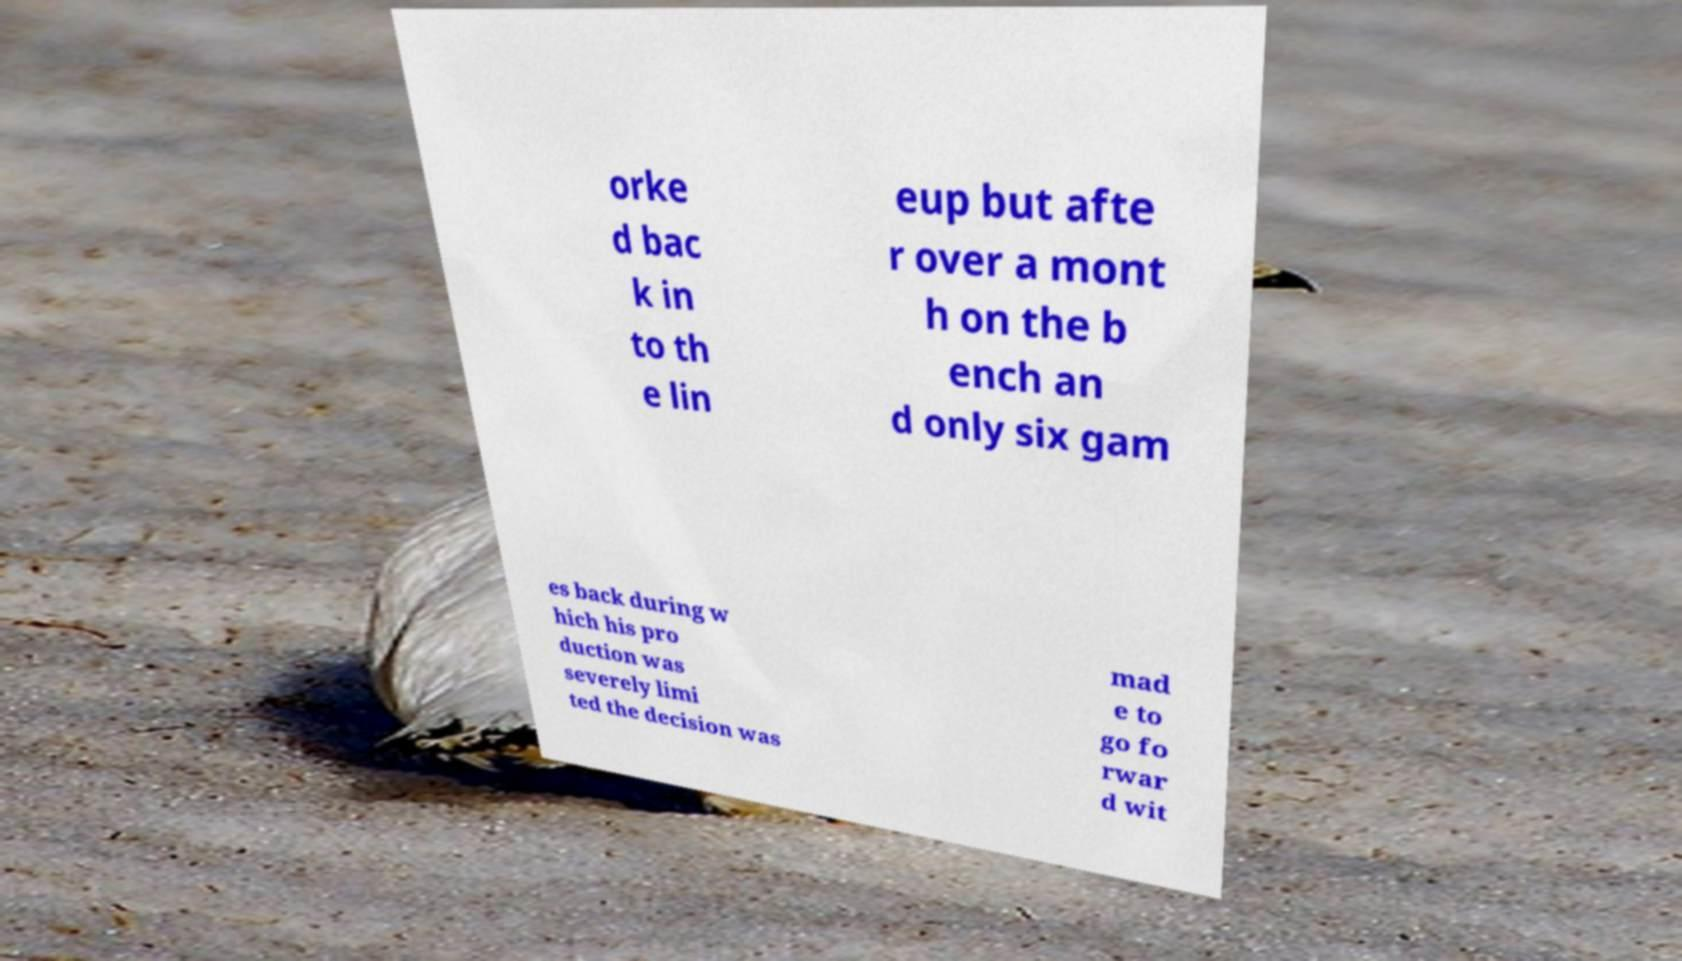Please identify and transcribe the text found in this image. orke d bac k in to th e lin eup but afte r over a mont h on the b ench an d only six gam es back during w hich his pro duction was severely limi ted the decision was mad e to go fo rwar d wit 